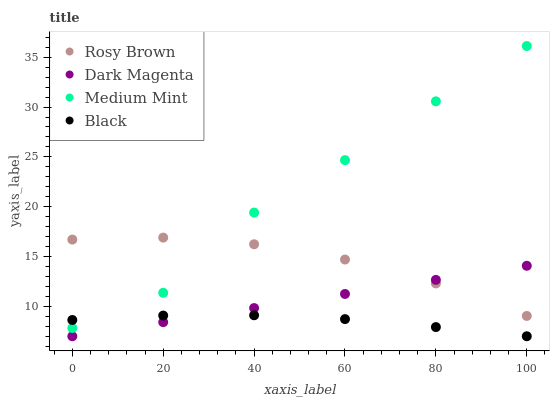Does Black have the minimum area under the curve?
Answer yes or no. Yes. Does Medium Mint have the maximum area under the curve?
Answer yes or no. Yes. Does Rosy Brown have the minimum area under the curve?
Answer yes or no. No. Does Rosy Brown have the maximum area under the curve?
Answer yes or no. No. Is Dark Magenta the smoothest?
Answer yes or no. Yes. Is Medium Mint the roughest?
Answer yes or no. Yes. Is Rosy Brown the smoothest?
Answer yes or no. No. Is Rosy Brown the roughest?
Answer yes or no. No. Does Black have the lowest value?
Answer yes or no. Yes. Does Rosy Brown have the lowest value?
Answer yes or no. No. Does Medium Mint have the highest value?
Answer yes or no. Yes. Does Rosy Brown have the highest value?
Answer yes or no. No. Is Black less than Rosy Brown?
Answer yes or no. Yes. Is Rosy Brown greater than Black?
Answer yes or no. Yes. Does Medium Mint intersect Rosy Brown?
Answer yes or no. Yes. Is Medium Mint less than Rosy Brown?
Answer yes or no. No. Is Medium Mint greater than Rosy Brown?
Answer yes or no. No. Does Black intersect Rosy Brown?
Answer yes or no. No. 